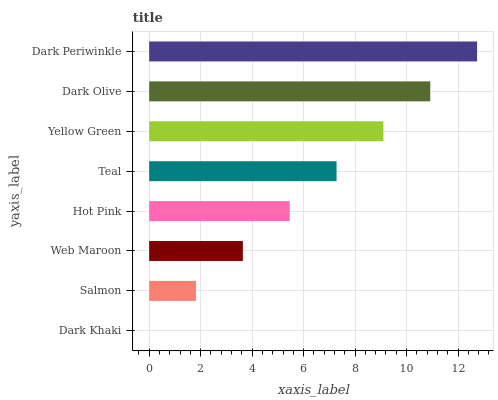Is Dark Khaki the minimum?
Answer yes or no. Yes. Is Dark Periwinkle the maximum?
Answer yes or no. Yes. Is Salmon the minimum?
Answer yes or no. No. Is Salmon the maximum?
Answer yes or no. No. Is Salmon greater than Dark Khaki?
Answer yes or no. Yes. Is Dark Khaki less than Salmon?
Answer yes or no. Yes. Is Dark Khaki greater than Salmon?
Answer yes or no. No. Is Salmon less than Dark Khaki?
Answer yes or no. No. Is Teal the high median?
Answer yes or no. Yes. Is Hot Pink the low median?
Answer yes or no. Yes. Is Web Maroon the high median?
Answer yes or no. No. Is Dark Khaki the low median?
Answer yes or no. No. 